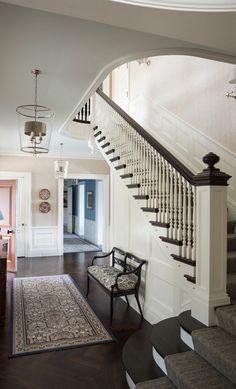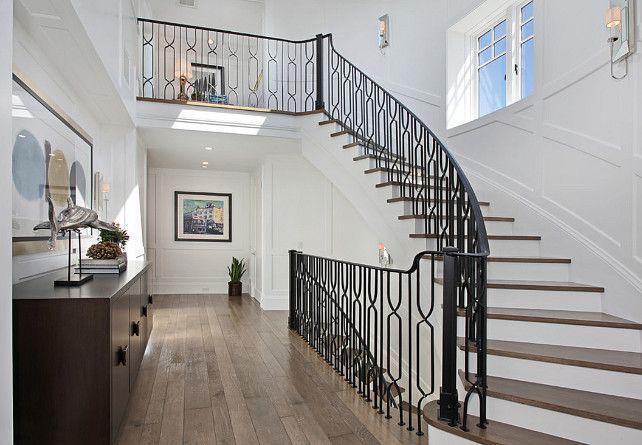The first image is the image on the left, the second image is the image on the right. Assess this claim about the two images: "One image shows a staircase that curves to the left as it descends and has brown steps with white base boards and a black handrail.". Correct or not? Answer yes or no. Yes. The first image is the image on the left, the second image is the image on the right. Analyze the images presented: Is the assertion "There is at least one vase with white flowers in it sitting on a table." valid? Answer yes or no. No. 